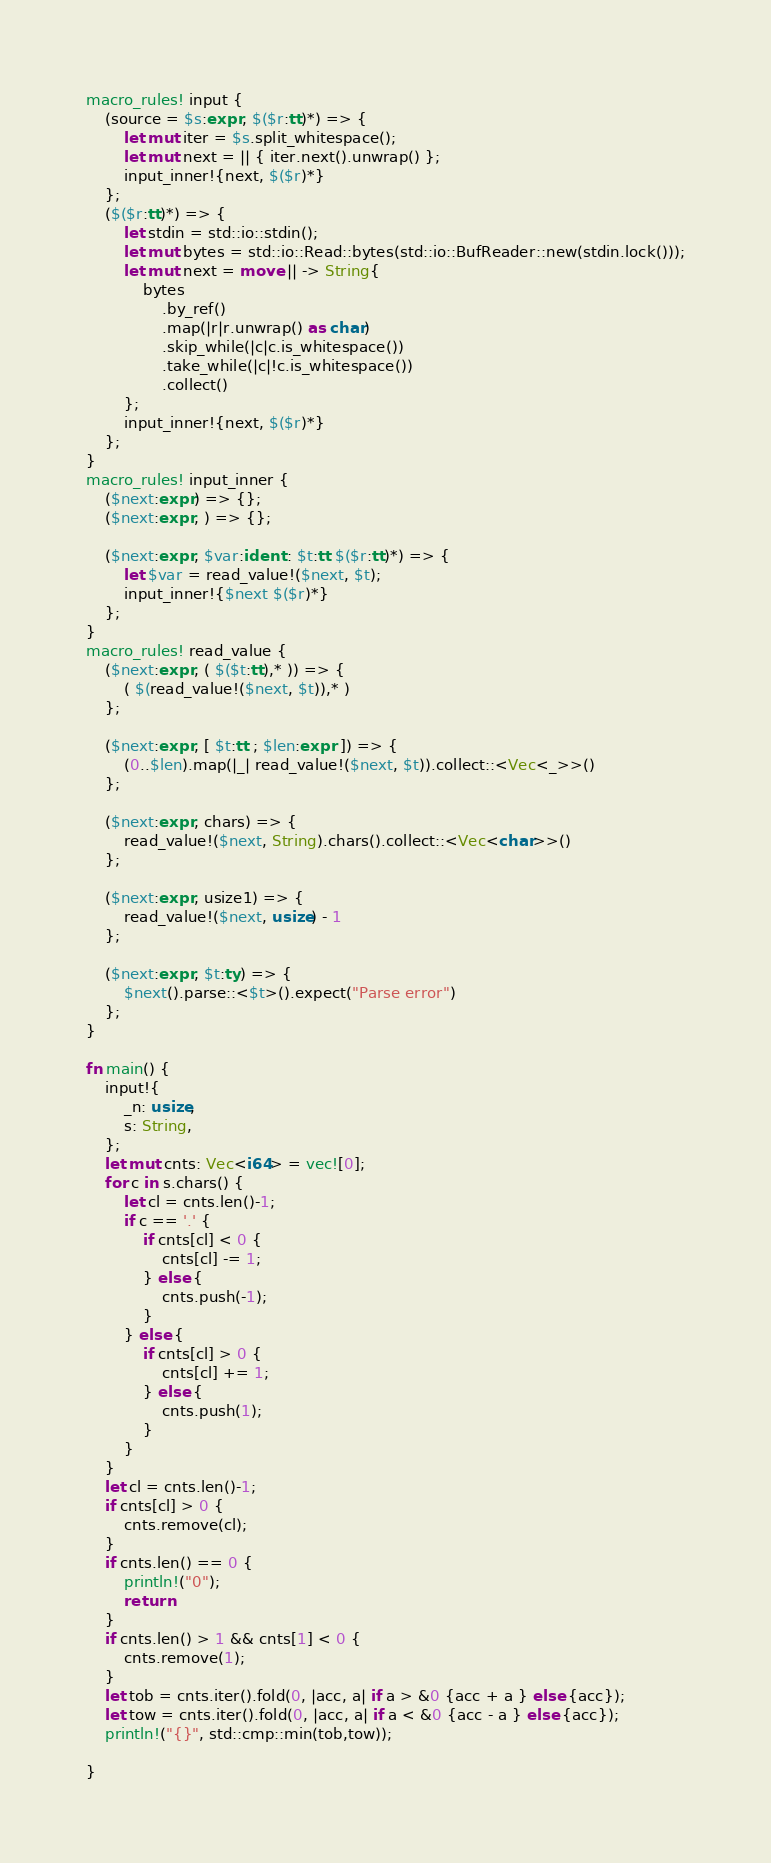Convert code to text. <code><loc_0><loc_0><loc_500><loc_500><_Rust_>macro_rules! input {
    (source = $s:expr, $($r:tt)*) => {
        let mut iter = $s.split_whitespace();
        let mut next = || { iter.next().unwrap() };
        input_inner!{next, $($r)*}
    };
    ($($r:tt)*) => {
        let stdin = std::io::stdin();
        let mut bytes = std::io::Read::bytes(std::io::BufReader::new(stdin.lock()));
        let mut next = move || -> String{
            bytes
                .by_ref()
                .map(|r|r.unwrap() as char)
                .skip_while(|c|c.is_whitespace())
                .take_while(|c|!c.is_whitespace())
                .collect()
        };
        input_inner!{next, $($r)*}
    };
}
macro_rules! input_inner {
    ($next:expr) => {};
    ($next:expr, ) => {};

    ($next:expr, $var:ident : $t:tt $($r:tt)*) => {
        let $var = read_value!($next, $t);
        input_inner!{$next $($r)*}
    };
}
macro_rules! read_value {
    ($next:expr, ( $($t:tt),* )) => {
        ( $(read_value!($next, $t)),* )
    };

    ($next:expr, [ $t:tt ; $len:expr ]) => {
        (0..$len).map(|_| read_value!($next, $t)).collect::<Vec<_>>()
    };

    ($next:expr, chars) => {
        read_value!($next, String).chars().collect::<Vec<char>>()
    };

    ($next:expr, usize1) => {
        read_value!($next, usize) - 1
    };

    ($next:expr, $t:ty) => {
        $next().parse::<$t>().expect("Parse error")
    };
}

fn main() {
    input!{
        _n: usize,
        s: String,
    };
    let mut cnts: Vec<i64> = vec![0];
    for c in s.chars() {
        let cl = cnts.len()-1;
        if c == '.' {
            if cnts[cl] < 0 {
                cnts[cl] -= 1;
            } else {
                cnts.push(-1);
            }
        } else {
            if cnts[cl] > 0 {
                cnts[cl] += 1;
            } else {
                cnts.push(1);
            }
        }
    }
    let cl = cnts.len()-1;
    if cnts[cl] > 0 {
        cnts.remove(cl);
    }
    if cnts.len() == 0 {
        println!("0");
        return
    }
    if cnts.len() > 1 && cnts[1] < 0 {
        cnts.remove(1);
    }
    let tob = cnts.iter().fold(0, |acc, a| if a > &0 {acc + a } else {acc});
    let tow = cnts.iter().fold(0, |acc, a| if a < &0 {acc - a } else {acc});
    println!("{}", std::cmp::min(tob,tow));

}</code> 